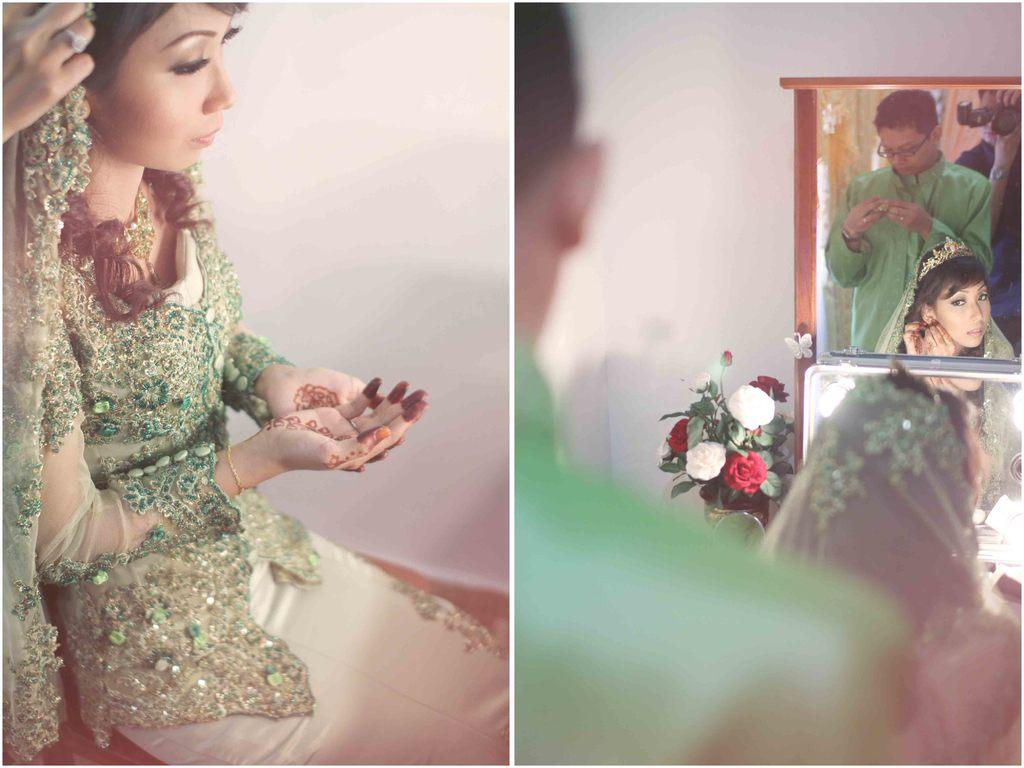What type of artwork is depicted in the image? The image is a collage. What elements are included in the collage? There are people, a mirror, flowers, and a wall in the collage. What is the function of the mirror in the collage? The mirror reflects people in the collage. What type of natural elements can be seen in the collage? There are flowers in the collage. What type of notebook is visible in the image? There is no notebook present in the image. What belief is represented by the people in the image? The image does not convey any specific beliefs; it is a collage of various elements. 